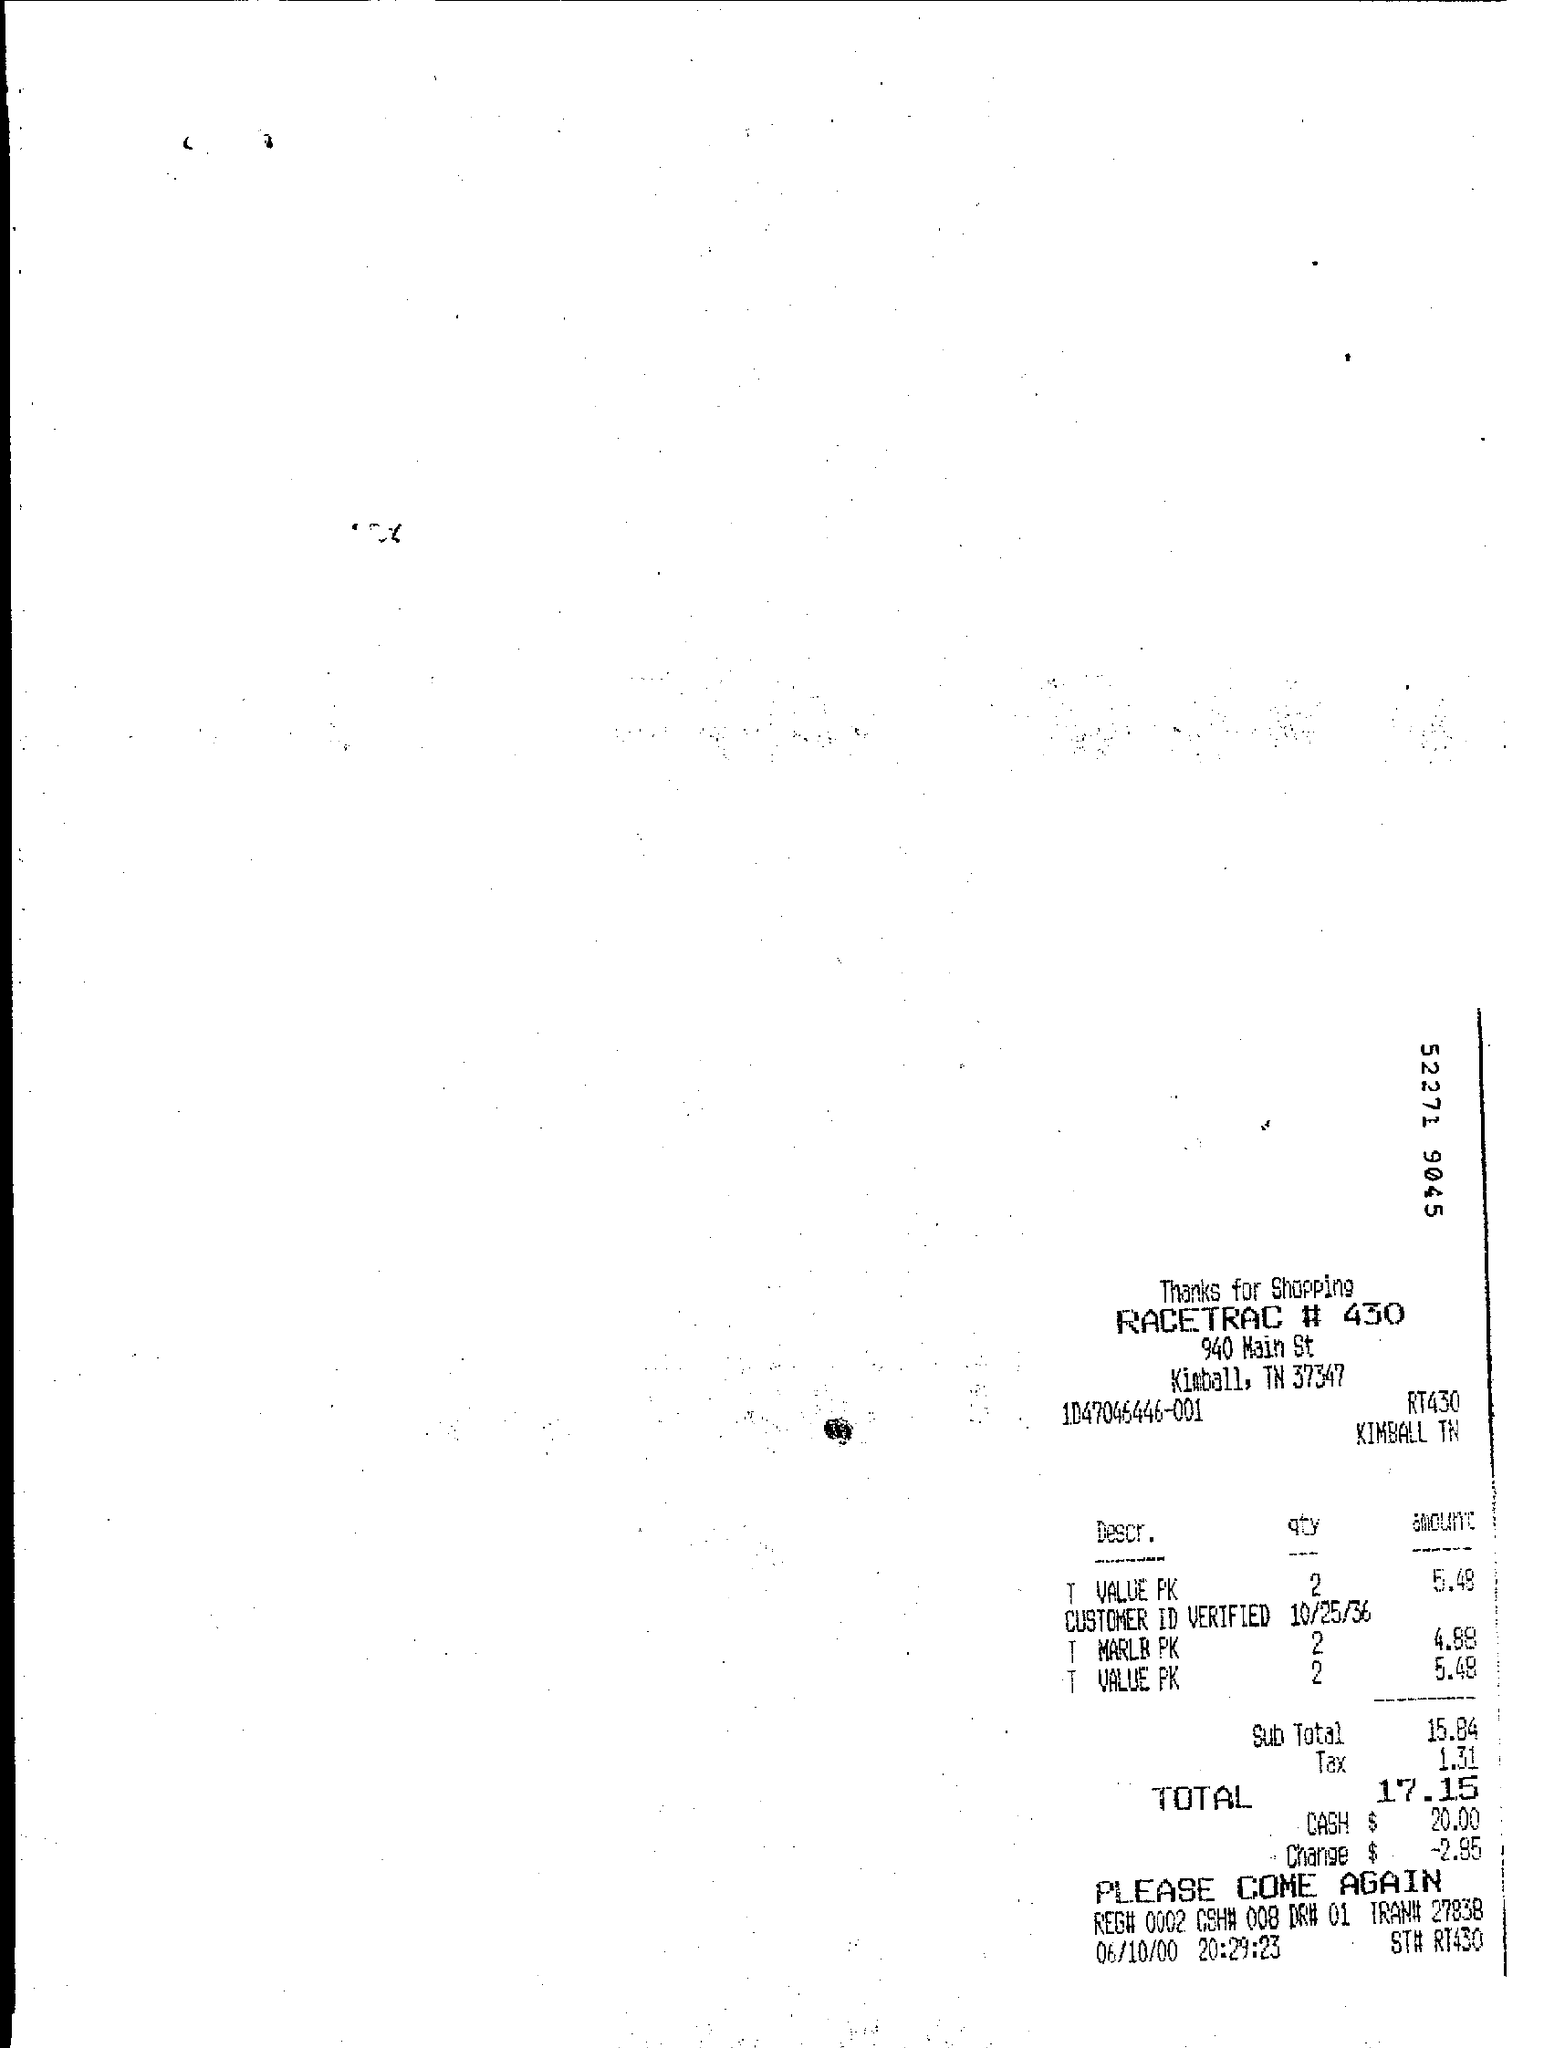What is the total amount spent in $?
Keep it short and to the point. $ 17.15. What is the tax in $ given?
Give a very brief answer. 1.31. How many T VALUE PK were purchased?
Give a very brief answer. 2. 